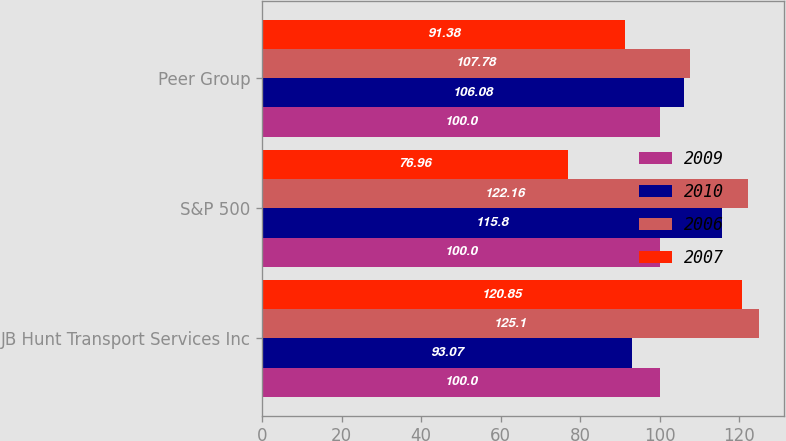Convert chart. <chart><loc_0><loc_0><loc_500><loc_500><stacked_bar_chart><ecel><fcel>JB Hunt Transport Services Inc<fcel>S&P 500<fcel>Peer Group<nl><fcel>2009<fcel>100<fcel>100<fcel>100<nl><fcel>2010<fcel>93.07<fcel>115.8<fcel>106.08<nl><fcel>2006<fcel>125.1<fcel>122.16<fcel>107.78<nl><fcel>2007<fcel>120.85<fcel>76.96<fcel>91.38<nl></chart> 